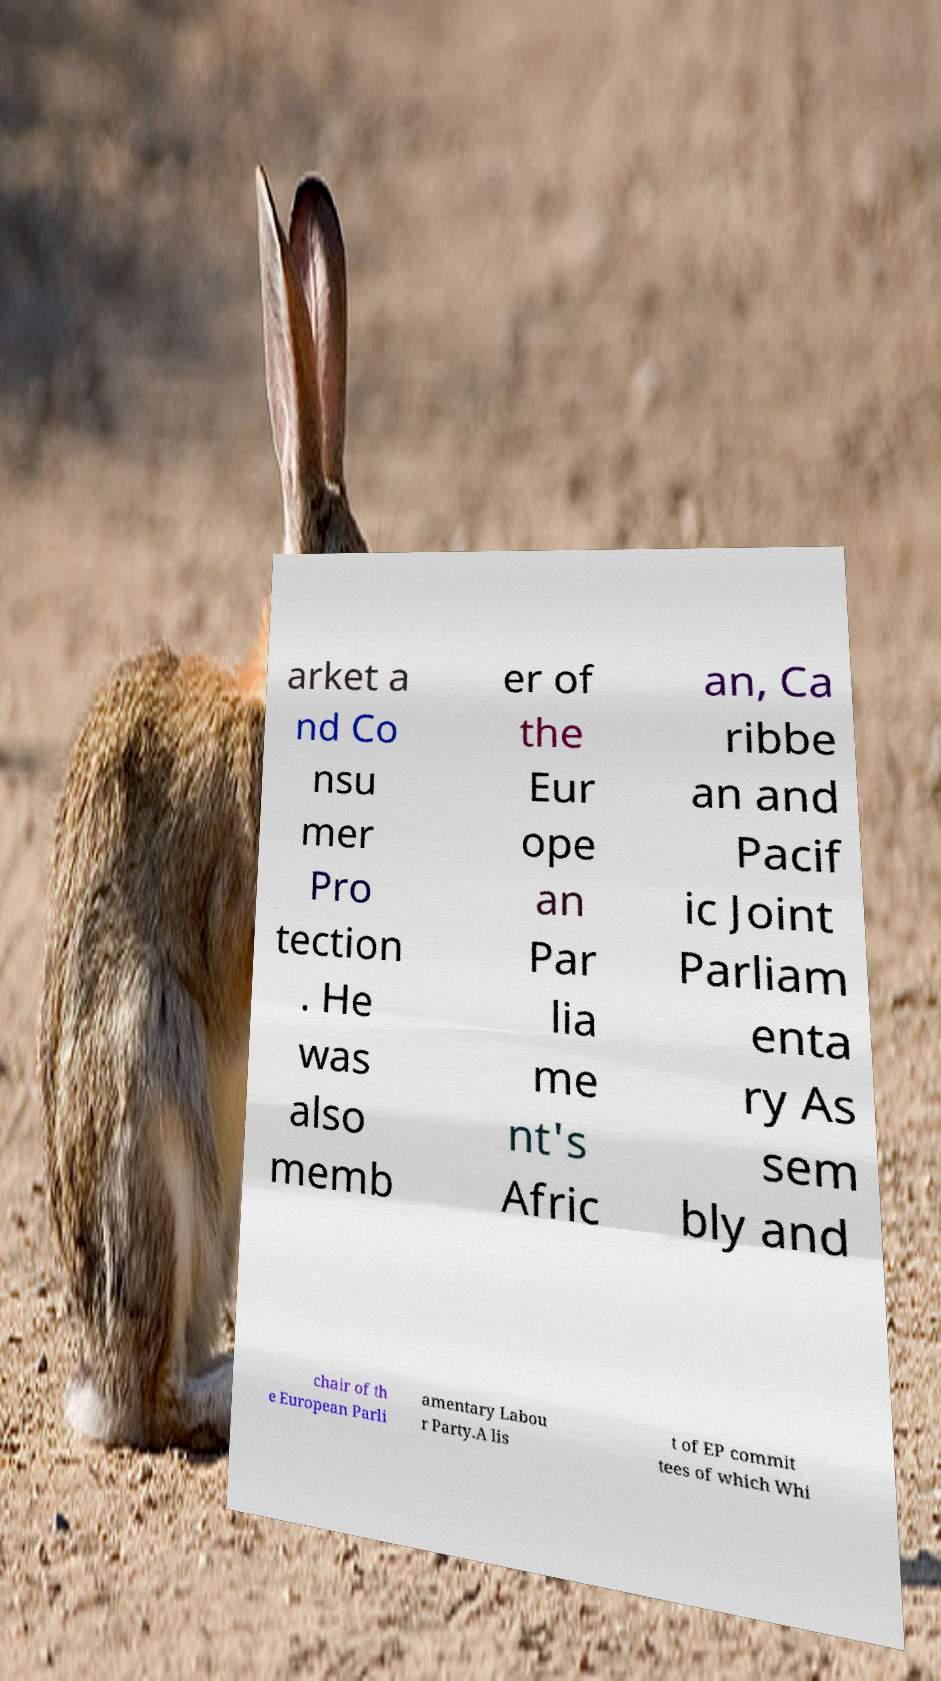Can you read and provide the text displayed in the image?This photo seems to have some interesting text. Can you extract and type it out for me? arket a nd Co nsu mer Pro tection . He was also memb er of the Eur ope an Par lia me nt's Afric an, Ca ribbe an and Pacif ic Joint Parliam enta ry As sem bly and chair of th e European Parli amentary Labou r Party.A lis t of EP commit tees of which Whi 